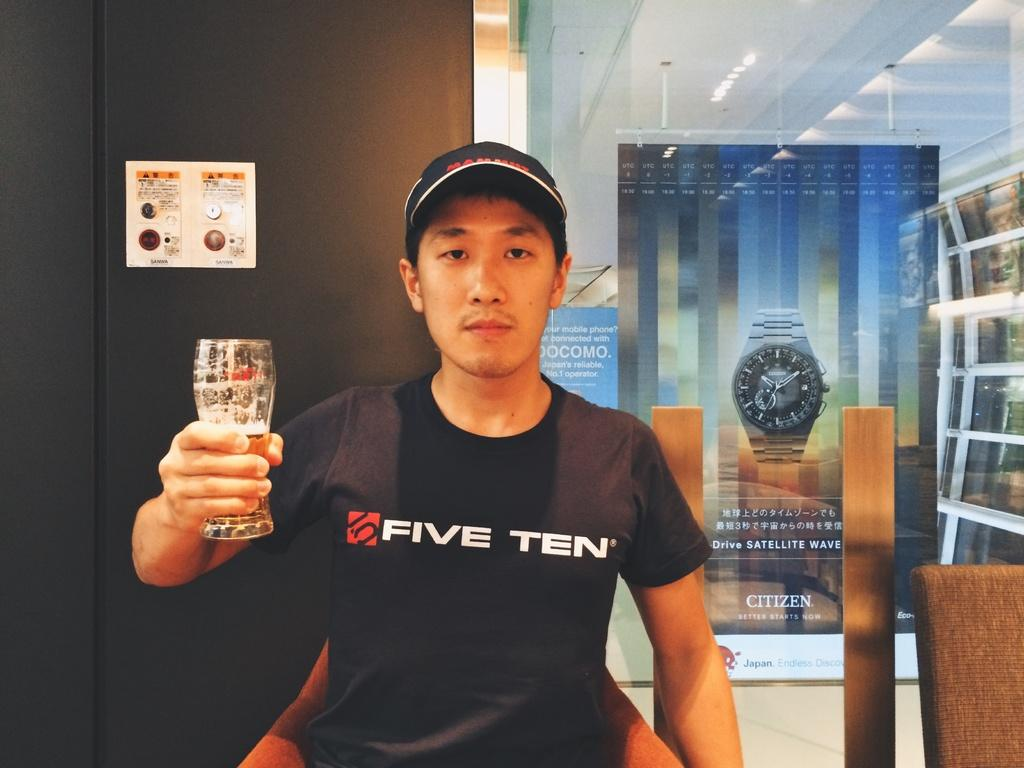<image>
Present a compact description of the photo's key features. Man holding a beer glass and wearing a black shirt with five ten in white. 